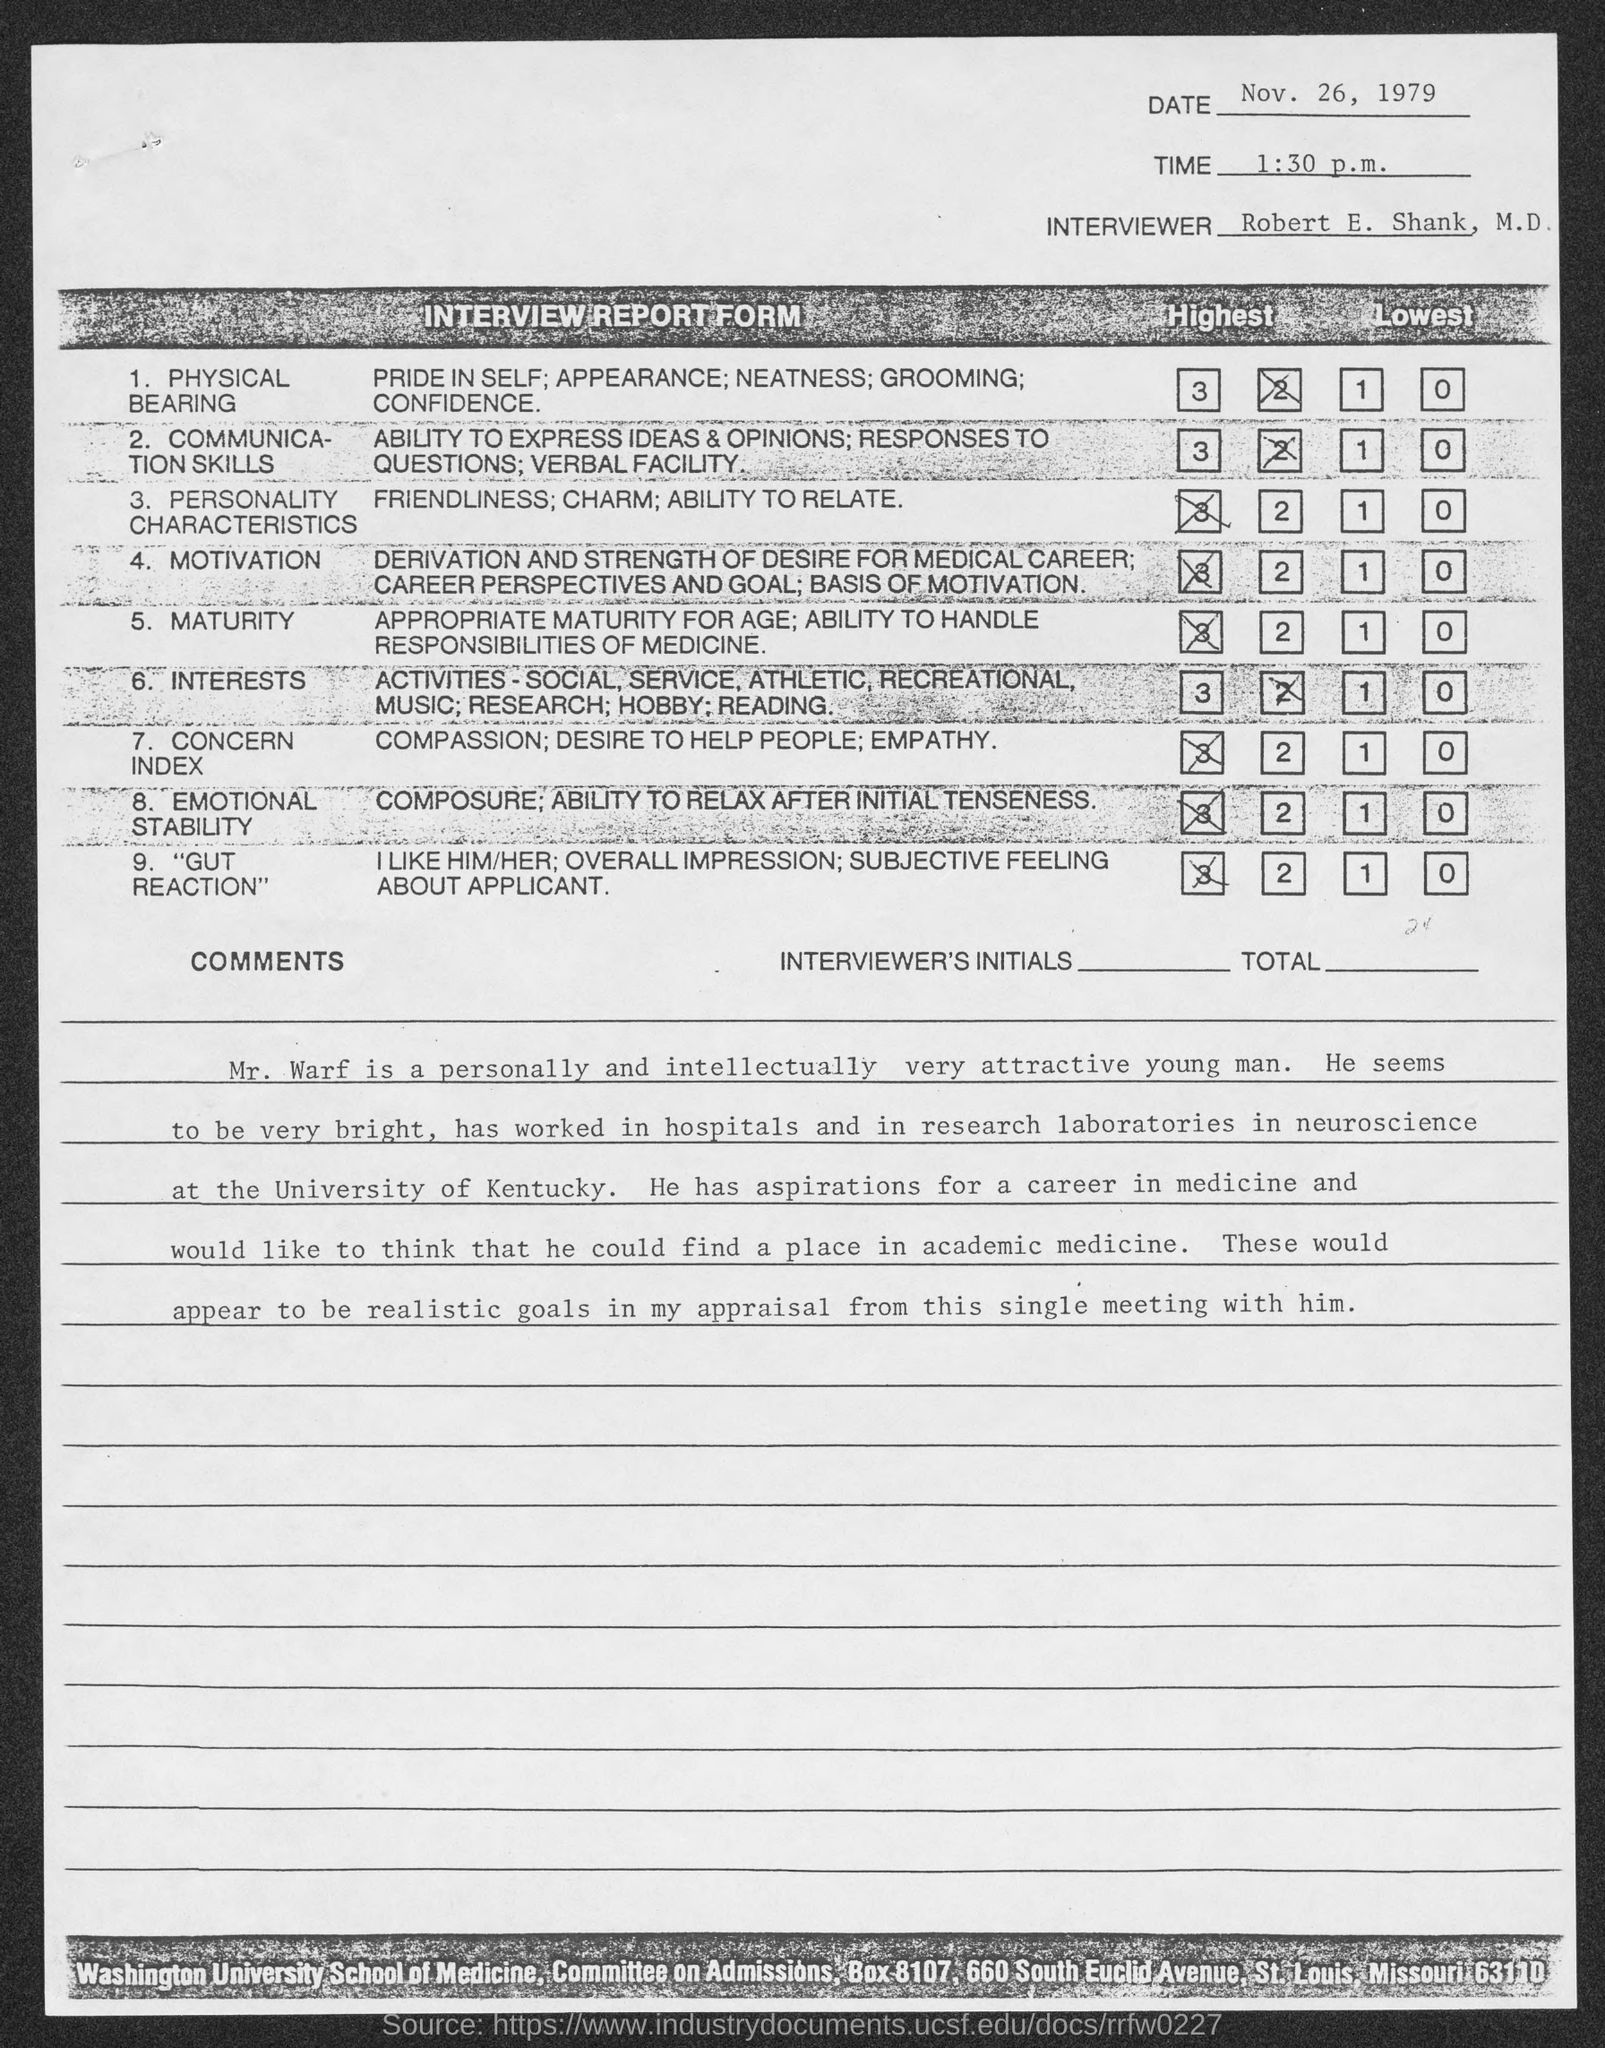Specify some key components in this picture. In the university hospitals and laboratories where Mr. Warf worked, he was affiliated with the University of Kentucky. 